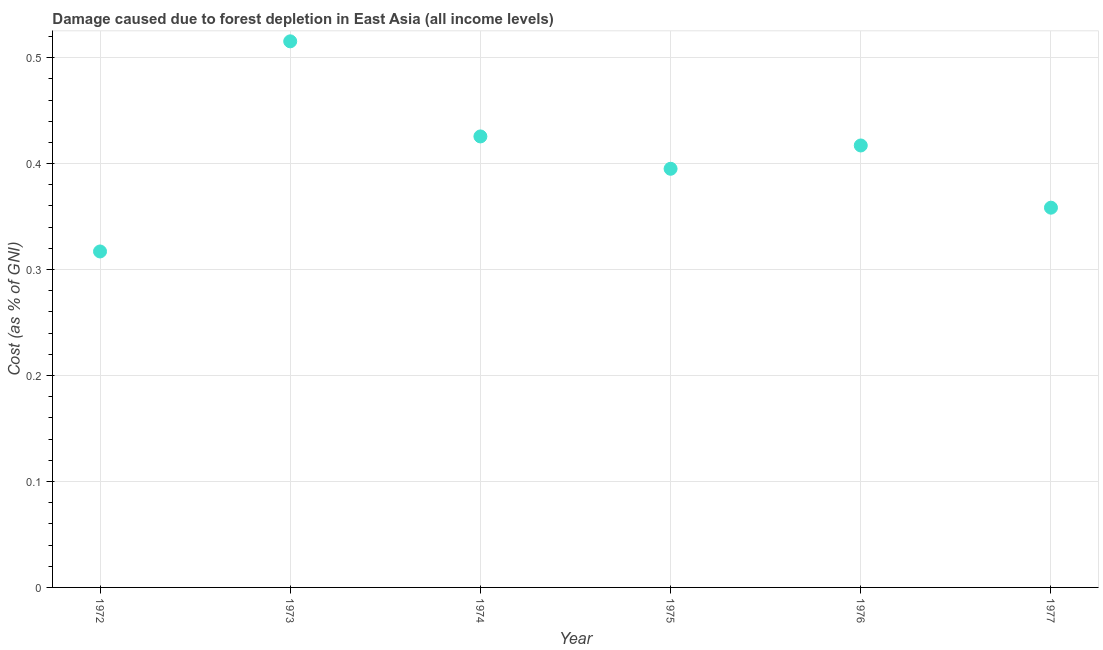What is the damage caused due to forest depletion in 1977?
Keep it short and to the point. 0.36. Across all years, what is the maximum damage caused due to forest depletion?
Ensure brevity in your answer.  0.52. Across all years, what is the minimum damage caused due to forest depletion?
Provide a succinct answer. 0.32. In which year was the damage caused due to forest depletion maximum?
Keep it short and to the point. 1973. In which year was the damage caused due to forest depletion minimum?
Your response must be concise. 1972. What is the sum of the damage caused due to forest depletion?
Offer a terse response. 2.43. What is the difference between the damage caused due to forest depletion in 1974 and 1975?
Give a very brief answer. 0.03. What is the average damage caused due to forest depletion per year?
Your answer should be very brief. 0.4. What is the median damage caused due to forest depletion?
Make the answer very short. 0.41. What is the ratio of the damage caused due to forest depletion in 1974 to that in 1977?
Provide a short and direct response. 1.19. What is the difference between the highest and the second highest damage caused due to forest depletion?
Give a very brief answer. 0.09. What is the difference between the highest and the lowest damage caused due to forest depletion?
Your answer should be very brief. 0.2. How many years are there in the graph?
Your answer should be compact. 6. What is the difference between two consecutive major ticks on the Y-axis?
Ensure brevity in your answer.  0.1. Does the graph contain grids?
Ensure brevity in your answer.  Yes. What is the title of the graph?
Offer a very short reply. Damage caused due to forest depletion in East Asia (all income levels). What is the label or title of the X-axis?
Offer a terse response. Year. What is the label or title of the Y-axis?
Your answer should be compact. Cost (as % of GNI). What is the Cost (as % of GNI) in 1972?
Keep it short and to the point. 0.32. What is the Cost (as % of GNI) in 1973?
Ensure brevity in your answer.  0.52. What is the Cost (as % of GNI) in 1974?
Ensure brevity in your answer.  0.43. What is the Cost (as % of GNI) in 1975?
Keep it short and to the point. 0.4. What is the Cost (as % of GNI) in 1976?
Your answer should be very brief. 0.42. What is the Cost (as % of GNI) in 1977?
Your response must be concise. 0.36. What is the difference between the Cost (as % of GNI) in 1972 and 1973?
Keep it short and to the point. -0.2. What is the difference between the Cost (as % of GNI) in 1972 and 1974?
Make the answer very short. -0.11. What is the difference between the Cost (as % of GNI) in 1972 and 1975?
Ensure brevity in your answer.  -0.08. What is the difference between the Cost (as % of GNI) in 1972 and 1976?
Ensure brevity in your answer.  -0.1. What is the difference between the Cost (as % of GNI) in 1972 and 1977?
Your answer should be compact. -0.04. What is the difference between the Cost (as % of GNI) in 1973 and 1974?
Your answer should be compact. 0.09. What is the difference between the Cost (as % of GNI) in 1973 and 1975?
Make the answer very short. 0.12. What is the difference between the Cost (as % of GNI) in 1973 and 1976?
Provide a succinct answer. 0.1. What is the difference between the Cost (as % of GNI) in 1973 and 1977?
Your answer should be very brief. 0.16. What is the difference between the Cost (as % of GNI) in 1974 and 1975?
Ensure brevity in your answer.  0.03. What is the difference between the Cost (as % of GNI) in 1974 and 1976?
Offer a terse response. 0.01. What is the difference between the Cost (as % of GNI) in 1974 and 1977?
Make the answer very short. 0.07. What is the difference between the Cost (as % of GNI) in 1975 and 1976?
Make the answer very short. -0.02. What is the difference between the Cost (as % of GNI) in 1975 and 1977?
Give a very brief answer. 0.04. What is the difference between the Cost (as % of GNI) in 1976 and 1977?
Give a very brief answer. 0.06. What is the ratio of the Cost (as % of GNI) in 1972 to that in 1973?
Provide a succinct answer. 0.61. What is the ratio of the Cost (as % of GNI) in 1972 to that in 1974?
Ensure brevity in your answer.  0.74. What is the ratio of the Cost (as % of GNI) in 1972 to that in 1975?
Provide a short and direct response. 0.8. What is the ratio of the Cost (as % of GNI) in 1972 to that in 1976?
Give a very brief answer. 0.76. What is the ratio of the Cost (as % of GNI) in 1972 to that in 1977?
Your answer should be very brief. 0.89. What is the ratio of the Cost (as % of GNI) in 1973 to that in 1974?
Provide a short and direct response. 1.21. What is the ratio of the Cost (as % of GNI) in 1973 to that in 1975?
Provide a short and direct response. 1.3. What is the ratio of the Cost (as % of GNI) in 1973 to that in 1976?
Make the answer very short. 1.24. What is the ratio of the Cost (as % of GNI) in 1973 to that in 1977?
Your answer should be very brief. 1.44. What is the ratio of the Cost (as % of GNI) in 1974 to that in 1975?
Your answer should be compact. 1.08. What is the ratio of the Cost (as % of GNI) in 1974 to that in 1976?
Keep it short and to the point. 1.02. What is the ratio of the Cost (as % of GNI) in 1974 to that in 1977?
Keep it short and to the point. 1.19. What is the ratio of the Cost (as % of GNI) in 1975 to that in 1976?
Provide a succinct answer. 0.95. What is the ratio of the Cost (as % of GNI) in 1975 to that in 1977?
Your answer should be very brief. 1.1. What is the ratio of the Cost (as % of GNI) in 1976 to that in 1977?
Offer a terse response. 1.16. 